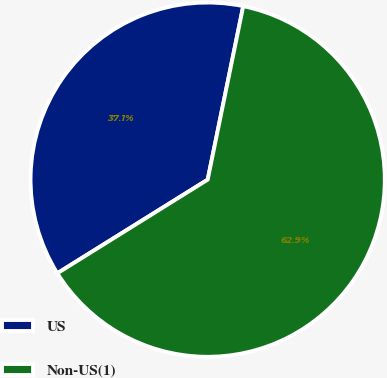<chart> <loc_0><loc_0><loc_500><loc_500><pie_chart><fcel>US<fcel>Non-US(1)<nl><fcel>37.08%<fcel>62.92%<nl></chart> 